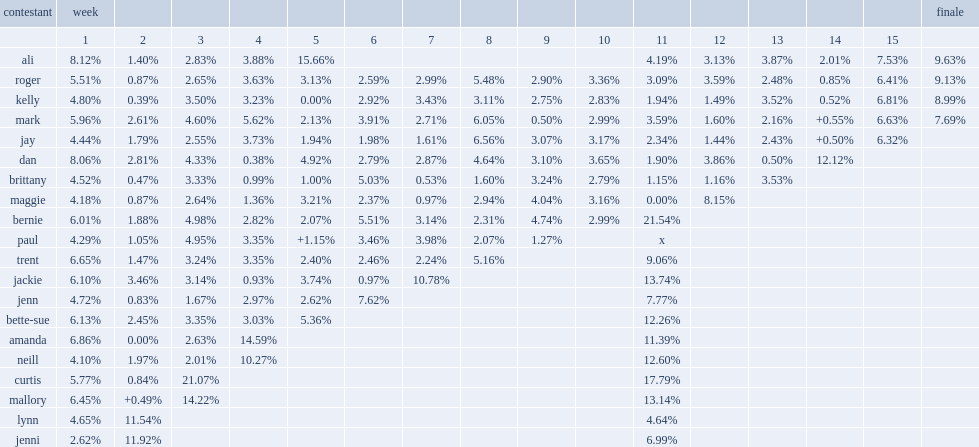What was the proportion of weight that roger lost in the 13 th week? 2.48. 